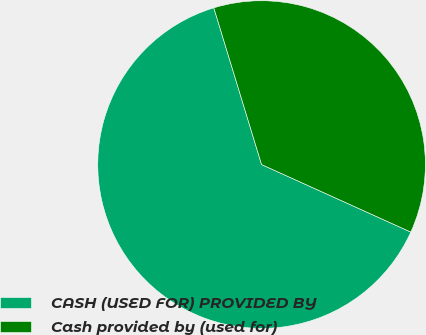<chart> <loc_0><loc_0><loc_500><loc_500><pie_chart><fcel>CASH (USED FOR) PROVIDED BY<fcel>Cash provided by (used for)<nl><fcel>63.53%<fcel>36.47%<nl></chart> 